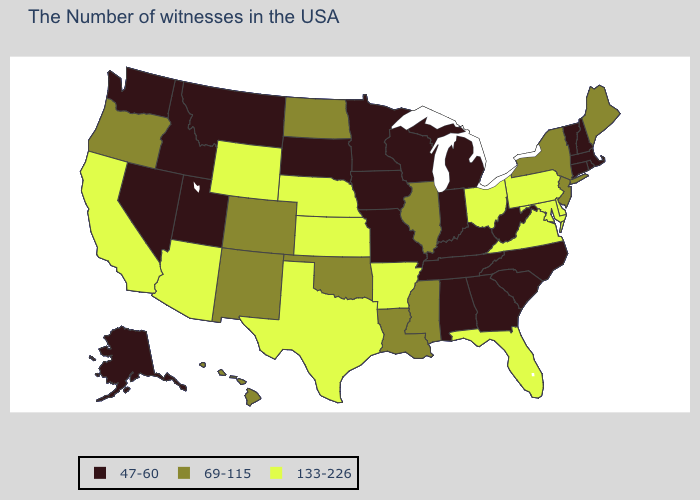What is the value of New Mexico?
Concise answer only. 69-115. Name the states that have a value in the range 69-115?
Keep it brief. Maine, New York, New Jersey, Illinois, Mississippi, Louisiana, Oklahoma, North Dakota, Colorado, New Mexico, Oregon, Hawaii. Does the map have missing data?
Give a very brief answer. No. What is the value of North Carolina?
Be succinct. 47-60. Does California have the same value as Minnesota?
Concise answer only. No. Which states have the lowest value in the West?
Concise answer only. Utah, Montana, Idaho, Nevada, Washington, Alaska. Name the states that have a value in the range 133-226?
Keep it brief. Delaware, Maryland, Pennsylvania, Virginia, Ohio, Florida, Arkansas, Kansas, Nebraska, Texas, Wyoming, Arizona, California. Name the states that have a value in the range 69-115?
Concise answer only. Maine, New York, New Jersey, Illinois, Mississippi, Louisiana, Oklahoma, North Dakota, Colorado, New Mexico, Oregon, Hawaii. What is the lowest value in the USA?
Write a very short answer. 47-60. Is the legend a continuous bar?
Concise answer only. No. What is the highest value in the MidWest ?
Short answer required. 133-226. What is the value of Massachusetts?
Quick response, please. 47-60. Does North Dakota have the same value as Florida?
Keep it brief. No. What is the value of Mississippi?
Short answer required. 69-115. Among the states that border Michigan , which have the lowest value?
Keep it brief. Indiana, Wisconsin. 